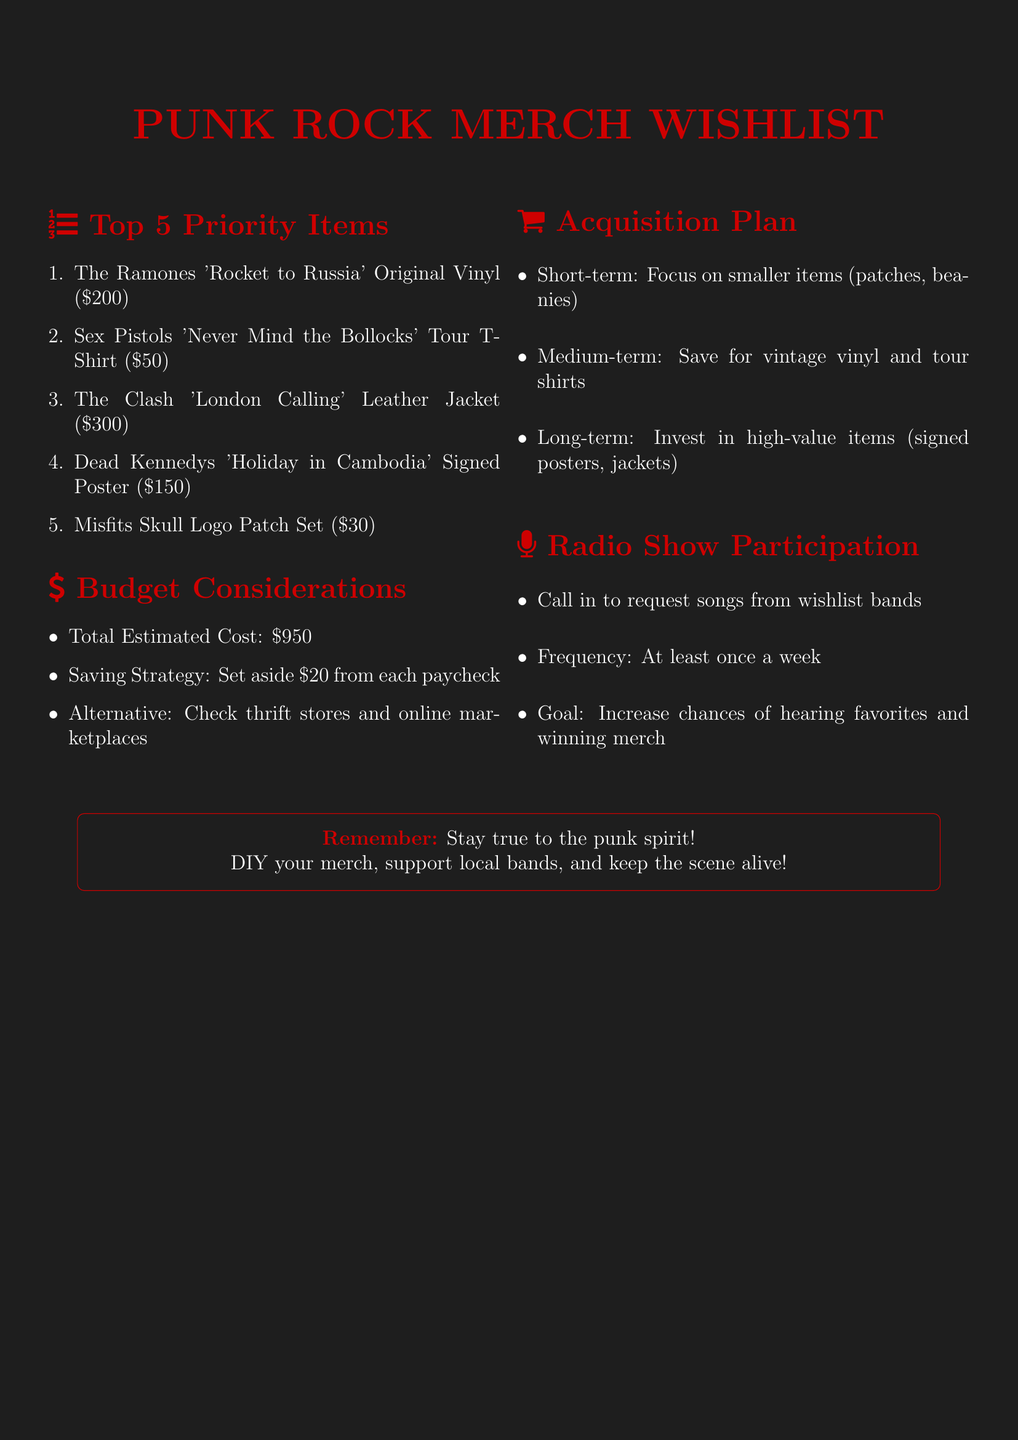What is the estimated cost of The Ramones 'Rocket to Russia' Original Vinyl? The cost listed for this item in the wishlist is $200.
Answer: $200 What is the priority number for the Dead Kennedys 'Holiday in Cambodia' Signed Poster? The priority number is found in the item's listing and is 4.
Answer: 4 What is the total estimated cost for the merchandise wishlist? The total cost is summarized in the budget section, which is $950.
Answer: $950 What is the main saving strategy mentioned? The saving strategy suggests to set aside $20 from each paycheck for a punk merchandise fund.
Answer: Set aside $20 from each paycheck Which item is recommended for customizing denim jackets and backpacks? The recommended item for this purpose is the Misfits Skull Logo Patch Set.
Answer: Misfits Skull Logo Patch Set How often should one call in to the radio show to request songs? The document states to call in at least once a week for song requests.
Answer: At least once a week What category does the Black Flag 'Bars' Logo Beanie fall under for budget considerations? The item is categorized as a smaller item, which is suitable for short-term acquisition plans.
Answer: Short-term What is the estimated cost of the Sex Pistols 'Never Mind the Bollocks' Tour T-Shirt? The estimated cost provided in the wishlist for this t-shirt is $50.
Answer: $50 What should be the focus for short-term acquisitions? The short-term focus should be on smaller items like patches and beanies.
Answer: Smaller items like patches and beanies 